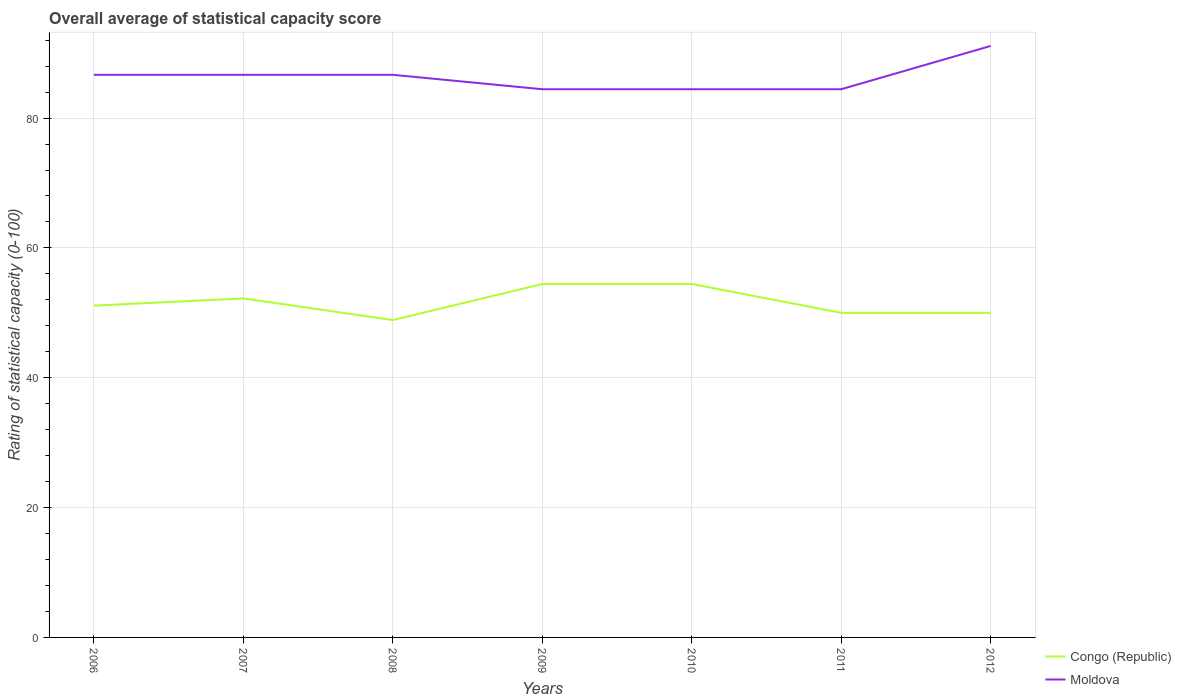How many different coloured lines are there?
Offer a terse response. 2. Does the line corresponding to Moldova intersect with the line corresponding to Congo (Republic)?
Keep it short and to the point. No. Across all years, what is the maximum rating of statistical capacity in Moldova?
Provide a succinct answer. 84.44. What is the total rating of statistical capacity in Moldova in the graph?
Give a very brief answer. 2.22. What is the difference between the highest and the second highest rating of statistical capacity in Congo (Republic)?
Your response must be concise. 5.56. Are the values on the major ticks of Y-axis written in scientific E-notation?
Offer a terse response. No. Does the graph contain any zero values?
Offer a very short reply. No. What is the title of the graph?
Your answer should be very brief. Overall average of statistical capacity score. What is the label or title of the X-axis?
Provide a short and direct response. Years. What is the label or title of the Y-axis?
Your response must be concise. Rating of statistical capacity (0-100). What is the Rating of statistical capacity (0-100) in Congo (Republic) in 2006?
Your answer should be compact. 51.11. What is the Rating of statistical capacity (0-100) in Moldova in 2006?
Offer a very short reply. 86.67. What is the Rating of statistical capacity (0-100) of Congo (Republic) in 2007?
Offer a very short reply. 52.22. What is the Rating of statistical capacity (0-100) in Moldova in 2007?
Provide a short and direct response. 86.67. What is the Rating of statistical capacity (0-100) of Congo (Republic) in 2008?
Your response must be concise. 48.89. What is the Rating of statistical capacity (0-100) of Moldova in 2008?
Your answer should be very brief. 86.67. What is the Rating of statistical capacity (0-100) in Congo (Republic) in 2009?
Your answer should be compact. 54.44. What is the Rating of statistical capacity (0-100) of Moldova in 2009?
Offer a terse response. 84.44. What is the Rating of statistical capacity (0-100) in Congo (Republic) in 2010?
Provide a succinct answer. 54.44. What is the Rating of statistical capacity (0-100) in Moldova in 2010?
Your answer should be compact. 84.44. What is the Rating of statistical capacity (0-100) of Moldova in 2011?
Provide a succinct answer. 84.44. What is the Rating of statistical capacity (0-100) of Moldova in 2012?
Provide a succinct answer. 91.11. Across all years, what is the maximum Rating of statistical capacity (0-100) in Congo (Republic)?
Your answer should be compact. 54.44. Across all years, what is the maximum Rating of statistical capacity (0-100) in Moldova?
Make the answer very short. 91.11. Across all years, what is the minimum Rating of statistical capacity (0-100) in Congo (Republic)?
Ensure brevity in your answer.  48.89. Across all years, what is the minimum Rating of statistical capacity (0-100) in Moldova?
Your response must be concise. 84.44. What is the total Rating of statistical capacity (0-100) in Congo (Republic) in the graph?
Offer a very short reply. 361.11. What is the total Rating of statistical capacity (0-100) of Moldova in the graph?
Your answer should be compact. 604.44. What is the difference between the Rating of statistical capacity (0-100) of Congo (Republic) in 2006 and that in 2007?
Make the answer very short. -1.11. What is the difference between the Rating of statistical capacity (0-100) of Moldova in 2006 and that in 2007?
Provide a short and direct response. 0. What is the difference between the Rating of statistical capacity (0-100) in Congo (Republic) in 2006 and that in 2008?
Offer a terse response. 2.22. What is the difference between the Rating of statistical capacity (0-100) in Moldova in 2006 and that in 2008?
Ensure brevity in your answer.  0. What is the difference between the Rating of statistical capacity (0-100) in Congo (Republic) in 2006 and that in 2009?
Your answer should be very brief. -3.33. What is the difference between the Rating of statistical capacity (0-100) in Moldova in 2006 and that in 2009?
Offer a very short reply. 2.22. What is the difference between the Rating of statistical capacity (0-100) of Moldova in 2006 and that in 2010?
Offer a terse response. 2.22. What is the difference between the Rating of statistical capacity (0-100) in Moldova in 2006 and that in 2011?
Provide a short and direct response. 2.22. What is the difference between the Rating of statistical capacity (0-100) of Moldova in 2006 and that in 2012?
Provide a succinct answer. -4.44. What is the difference between the Rating of statistical capacity (0-100) in Congo (Republic) in 2007 and that in 2009?
Your response must be concise. -2.22. What is the difference between the Rating of statistical capacity (0-100) of Moldova in 2007 and that in 2009?
Provide a succinct answer. 2.22. What is the difference between the Rating of statistical capacity (0-100) in Congo (Republic) in 2007 and that in 2010?
Your response must be concise. -2.22. What is the difference between the Rating of statistical capacity (0-100) in Moldova in 2007 and that in 2010?
Give a very brief answer. 2.22. What is the difference between the Rating of statistical capacity (0-100) of Congo (Republic) in 2007 and that in 2011?
Make the answer very short. 2.22. What is the difference between the Rating of statistical capacity (0-100) in Moldova in 2007 and that in 2011?
Your answer should be very brief. 2.22. What is the difference between the Rating of statistical capacity (0-100) of Congo (Republic) in 2007 and that in 2012?
Your answer should be very brief. 2.22. What is the difference between the Rating of statistical capacity (0-100) in Moldova in 2007 and that in 2012?
Keep it short and to the point. -4.44. What is the difference between the Rating of statistical capacity (0-100) of Congo (Republic) in 2008 and that in 2009?
Your response must be concise. -5.56. What is the difference between the Rating of statistical capacity (0-100) in Moldova in 2008 and that in 2009?
Ensure brevity in your answer.  2.22. What is the difference between the Rating of statistical capacity (0-100) of Congo (Republic) in 2008 and that in 2010?
Keep it short and to the point. -5.56. What is the difference between the Rating of statistical capacity (0-100) of Moldova in 2008 and that in 2010?
Keep it short and to the point. 2.22. What is the difference between the Rating of statistical capacity (0-100) of Congo (Republic) in 2008 and that in 2011?
Provide a short and direct response. -1.11. What is the difference between the Rating of statistical capacity (0-100) of Moldova in 2008 and that in 2011?
Keep it short and to the point. 2.22. What is the difference between the Rating of statistical capacity (0-100) of Congo (Republic) in 2008 and that in 2012?
Give a very brief answer. -1.11. What is the difference between the Rating of statistical capacity (0-100) of Moldova in 2008 and that in 2012?
Make the answer very short. -4.44. What is the difference between the Rating of statistical capacity (0-100) of Congo (Republic) in 2009 and that in 2011?
Your response must be concise. 4.44. What is the difference between the Rating of statistical capacity (0-100) of Congo (Republic) in 2009 and that in 2012?
Your answer should be compact. 4.44. What is the difference between the Rating of statistical capacity (0-100) of Moldova in 2009 and that in 2012?
Keep it short and to the point. -6.67. What is the difference between the Rating of statistical capacity (0-100) of Congo (Republic) in 2010 and that in 2011?
Provide a succinct answer. 4.44. What is the difference between the Rating of statistical capacity (0-100) of Moldova in 2010 and that in 2011?
Your answer should be compact. 0. What is the difference between the Rating of statistical capacity (0-100) of Congo (Republic) in 2010 and that in 2012?
Provide a short and direct response. 4.44. What is the difference between the Rating of statistical capacity (0-100) in Moldova in 2010 and that in 2012?
Provide a short and direct response. -6.67. What is the difference between the Rating of statistical capacity (0-100) in Congo (Republic) in 2011 and that in 2012?
Provide a succinct answer. 0. What is the difference between the Rating of statistical capacity (0-100) of Moldova in 2011 and that in 2012?
Your response must be concise. -6.67. What is the difference between the Rating of statistical capacity (0-100) of Congo (Republic) in 2006 and the Rating of statistical capacity (0-100) of Moldova in 2007?
Ensure brevity in your answer.  -35.56. What is the difference between the Rating of statistical capacity (0-100) of Congo (Republic) in 2006 and the Rating of statistical capacity (0-100) of Moldova in 2008?
Ensure brevity in your answer.  -35.56. What is the difference between the Rating of statistical capacity (0-100) in Congo (Republic) in 2006 and the Rating of statistical capacity (0-100) in Moldova in 2009?
Provide a short and direct response. -33.33. What is the difference between the Rating of statistical capacity (0-100) of Congo (Republic) in 2006 and the Rating of statistical capacity (0-100) of Moldova in 2010?
Offer a terse response. -33.33. What is the difference between the Rating of statistical capacity (0-100) in Congo (Republic) in 2006 and the Rating of statistical capacity (0-100) in Moldova in 2011?
Your answer should be very brief. -33.33. What is the difference between the Rating of statistical capacity (0-100) in Congo (Republic) in 2007 and the Rating of statistical capacity (0-100) in Moldova in 2008?
Ensure brevity in your answer.  -34.44. What is the difference between the Rating of statistical capacity (0-100) of Congo (Republic) in 2007 and the Rating of statistical capacity (0-100) of Moldova in 2009?
Keep it short and to the point. -32.22. What is the difference between the Rating of statistical capacity (0-100) in Congo (Republic) in 2007 and the Rating of statistical capacity (0-100) in Moldova in 2010?
Your response must be concise. -32.22. What is the difference between the Rating of statistical capacity (0-100) of Congo (Republic) in 2007 and the Rating of statistical capacity (0-100) of Moldova in 2011?
Your answer should be compact. -32.22. What is the difference between the Rating of statistical capacity (0-100) in Congo (Republic) in 2007 and the Rating of statistical capacity (0-100) in Moldova in 2012?
Your answer should be compact. -38.89. What is the difference between the Rating of statistical capacity (0-100) in Congo (Republic) in 2008 and the Rating of statistical capacity (0-100) in Moldova in 2009?
Provide a short and direct response. -35.56. What is the difference between the Rating of statistical capacity (0-100) of Congo (Republic) in 2008 and the Rating of statistical capacity (0-100) of Moldova in 2010?
Your answer should be compact. -35.56. What is the difference between the Rating of statistical capacity (0-100) of Congo (Republic) in 2008 and the Rating of statistical capacity (0-100) of Moldova in 2011?
Your answer should be very brief. -35.56. What is the difference between the Rating of statistical capacity (0-100) of Congo (Republic) in 2008 and the Rating of statistical capacity (0-100) of Moldova in 2012?
Make the answer very short. -42.22. What is the difference between the Rating of statistical capacity (0-100) in Congo (Republic) in 2009 and the Rating of statistical capacity (0-100) in Moldova in 2010?
Offer a terse response. -30. What is the difference between the Rating of statistical capacity (0-100) of Congo (Republic) in 2009 and the Rating of statistical capacity (0-100) of Moldova in 2012?
Ensure brevity in your answer.  -36.67. What is the difference between the Rating of statistical capacity (0-100) of Congo (Republic) in 2010 and the Rating of statistical capacity (0-100) of Moldova in 2011?
Your answer should be very brief. -30. What is the difference between the Rating of statistical capacity (0-100) of Congo (Republic) in 2010 and the Rating of statistical capacity (0-100) of Moldova in 2012?
Keep it short and to the point. -36.67. What is the difference between the Rating of statistical capacity (0-100) in Congo (Republic) in 2011 and the Rating of statistical capacity (0-100) in Moldova in 2012?
Your answer should be compact. -41.11. What is the average Rating of statistical capacity (0-100) in Congo (Republic) per year?
Your answer should be very brief. 51.59. What is the average Rating of statistical capacity (0-100) in Moldova per year?
Offer a terse response. 86.35. In the year 2006, what is the difference between the Rating of statistical capacity (0-100) in Congo (Republic) and Rating of statistical capacity (0-100) in Moldova?
Keep it short and to the point. -35.56. In the year 2007, what is the difference between the Rating of statistical capacity (0-100) in Congo (Republic) and Rating of statistical capacity (0-100) in Moldova?
Your answer should be very brief. -34.44. In the year 2008, what is the difference between the Rating of statistical capacity (0-100) of Congo (Republic) and Rating of statistical capacity (0-100) of Moldova?
Make the answer very short. -37.78. In the year 2011, what is the difference between the Rating of statistical capacity (0-100) in Congo (Republic) and Rating of statistical capacity (0-100) in Moldova?
Provide a succinct answer. -34.44. In the year 2012, what is the difference between the Rating of statistical capacity (0-100) in Congo (Republic) and Rating of statistical capacity (0-100) in Moldova?
Ensure brevity in your answer.  -41.11. What is the ratio of the Rating of statistical capacity (0-100) in Congo (Republic) in 2006 to that in 2007?
Offer a very short reply. 0.98. What is the ratio of the Rating of statistical capacity (0-100) in Congo (Republic) in 2006 to that in 2008?
Make the answer very short. 1.05. What is the ratio of the Rating of statistical capacity (0-100) of Moldova in 2006 to that in 2008?
Give a very brief answer. 1. What is the ratio of the Rating of statistical capacity (0-100) in Congo (Republic) in 2006 to that in 2009?
Provide a short and direct response. 0.94. What is the ratio of the Rating of statistical capacity (0-100) of Moldova in 2006 to that in 2009?
Make the answer very short. 1.03. What is the ratio of the Rating of statistical capacity (0-100) in Congo (Republic) in 2006 to that in 2010?
Give a very brief answer. 0.94. What is the ratio of the Rating of statistical capacity (0-100) in Moldova in 2006 to that in 2010?
Your answer should be very brief. 1.03. What is the ratio of the Rating of statistical capacity (0-100) of Congo (Republic) in 2006 to that in 2011?
Offer a very short reply. 1.02. What is the ratio of the Rating of statistical capacity (0-100) in Moldova in 2006 to that in 2011?
Make the answer very short. 1.03. What is the ratio of the Rating of statistical capacity (0-100) of Congo (Republic) in 2006 to that in 2012?
Your response must be concise. 1.02. What is the ratio of the Rating of statistical capacity (0-100) of Moldova in 2006 to that in 2012?
Give a very brief answer. 0.95. What is the ratio of the Rating of statistical capacity (0-100) in Congo (Republic) in 2007 to that in 2008?
Ensure brevity in your answer.  1.07. What is the ratio of the Rating of statistical capacity (0-100) in Congo (Republic) in 2007 to that in 2009?
Your answer should be very brief. 0.96. What is the ratio of the Rating of statistical capacity (0-100) in Moldova in 2007 to that in 2009?
Give a very brief answer. 1.03. What is the ratio of the Rating of statistical capacity (0-100) of Congo (Republic) in 2007 to that in 2010?
Provide a succinct answer. 0.96. What is the ratio of the Rating of statistical capacity (0-100) in Moldova in 2007 to that in 2010?
Your answer should be very brief. 1.03. What is the ratio of the Rating of statistical capacity (0-100) of Congo (Republic) in 2007 to that in 2011?
Offer a very short reply. 1.04. What is the ratio of the Rating of statistical capacity (0-100) in Moldova in 2007 to that in 2011?
Offer a terse response. 1.03. What is the ratio of the Rating of statistical capacity (0-100) in Congo (Republic) in 2007 to that in 2012?
Give a very brief answer. 1.04. What is the ratio of the Rating of statistical capacity (0-100) of Moldova in 2007 to that in 2012?
Give a very brief answer. 0.95. What is the ratio of the Rating of statistical capacity (0-100) in Congo (Republic) in 2008 to that in 2009?
Provide a short and direct response. 0.9. What is the ratio of the Rating of statistical capacity (0-100) in Moldova in 2008 to that in 2009?
Make the answer very short. 1.03. What is the ratio of the Rating of statistical capacity (0-100) in Congo (Republic) in 2008 to that in 2010?
Provide a short and direct response. 0.9. What is the ratio of the Rating of statistical capacity (0-100) of Moldova in 2008 to that in 2010?
Offer a very short reply. 1.03. What is the ratio of the Rating of statistical capacity (0-100) of Congo (Republic) in 2008 to that in 2011?
Give a very brief answer. 0.98. What is the ratio of the Rating of statistical capacity (0-100) in Moldova in 2008 to that in 2011?
Keep it short and to the point. 1.03. What is the ratio of the Rating of statistical capacity (0-100) in Congo (Republic) in 2008 to that in 2012?
Your response must be concise. 0.98. What is the ratio of the Rating of statistical capacity (0-100) in Moldova in 2008 to that in 2012?
Ensure brevity in your answer.  0.95. What is the ratio of the Rating of statistical capacity (0-100) in Congo (Republic) in 2009 to that in 2010?
Make the answer very short. 1. What is the ratio of the Rating of statistical capacity (0-100) of Congo (Republic) in 2009 to that in 2011?
Provide a short and direct response. 1.09. What is the ratio of the Rating of statistical capacity (0-100) of Moldova in 2009 to that in 2011?
Ensure brevity in your answer.  1. What is the ratio of the Rating of statistical capacity (0-100) in Congo (Republic) in 2009 to that in 2012?
Offer a very short reply. 1.09. What is the ratio of the Rating of statistical capacity (0-100) in Moldova in 2009 to that in 2012?
Offer a very short reply. 0.93. What is the ratio of the Rating of statistical capacity (0-100) of Congo (Republic) in 2010 to that in 2011?
Ensure brevity in your answer.  1.09. What is the ratio of the Rating of statistical capacity (0-100) of Congo (Republic) in 2010 to that in 2012?
Your answer should be very brief. 1.09. What is the ratio of the Rating of statistical capacity (0-100) of Moldova in 2010 to that in 2012?
Make the answer very short. 0.93. What is the ratio of the Rating of statistical capacity (0-100) of Congo (Republic) in 2011 to that in 2012?
Give a very brief answer. 1. What is the ratio of the Rating of statistical capacity (0-100) in Moldova in 2011 to that in 2012?
Give a very brief answer. 0.93. What is the difference between the highest and the second highest Rating of statistical capacity (0-100) of Congo (Republic)?
Your response must be concise. 0. What is the difference between the highest and the second highest Rating of statistical capacity (0-100) of Moldova?
Ensure brevity in your answer.  4.44. What is the difference between the highest and the lowest Rating of statistical capacity (0-100) in Congo (Republic)?
Give a very brief answer. 5.56. What is the difference between the highest and the lowest Rating of statistical capacity (0-100) of Moldova?
Your response must be concise. 6.67. 